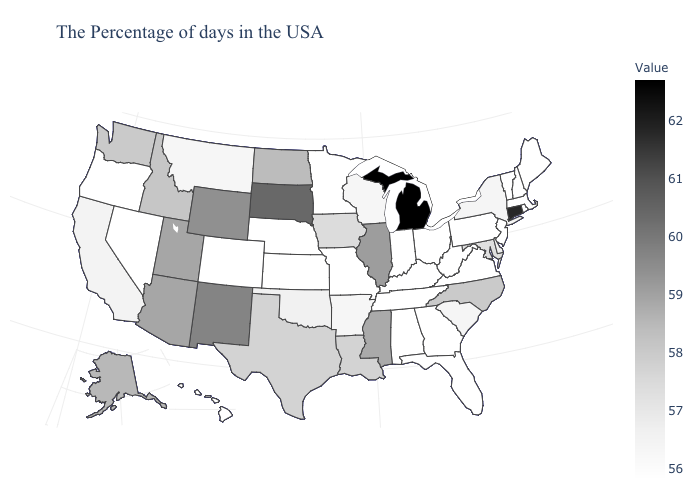Which states hav the highest value in the West?
Give a very brief answer. New Mexico. Which states hav the highest value in the MidWest?
Be succinct. Michigan. Among the states that border Washington , which have the lowest value?
Quick response, please. Oregon. Does Alaska have the highest value in the USA?
Quick response, please. No. Does Nevada have the highest value in the West?
Keep it brief. No. Does the map have missing data?
Give a very brief answer. No. Does Louisiana have the lowest value in the South?
Write a very short answer. No. 